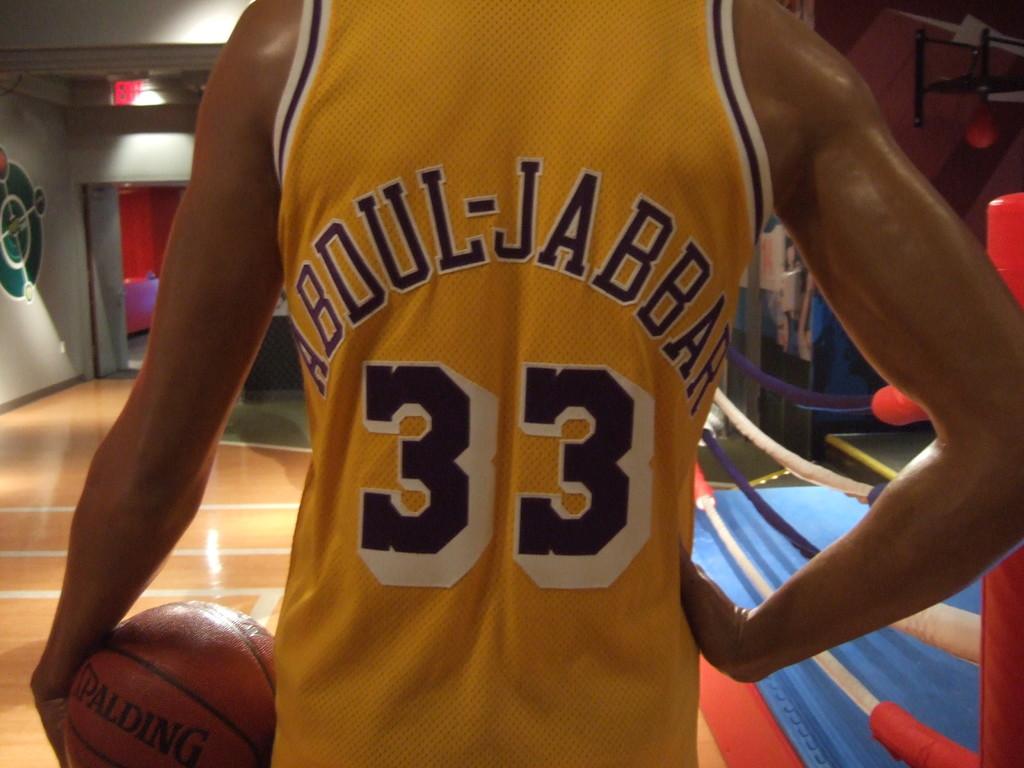What is the name of this basketball player?
Your response must be concise. Abdul-jabbar. What number is on the jerseey?
Your answer should be very brief. 33. 